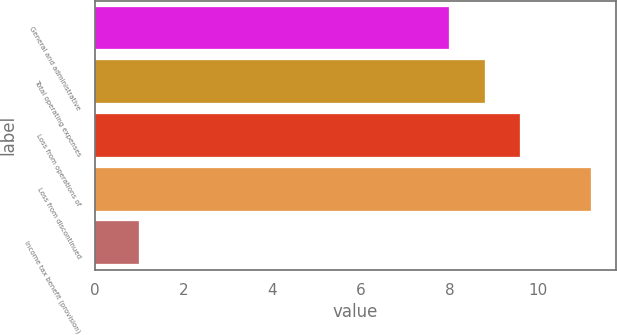Convert chart. <chart><loc_0><loc_0><loc_500><loc_500><bar_chart><fcel>General and administrative<fcel>Total operating expenses<fcel>Loss from operations of<fcel>Loss from discontinued<fcel>Income tax benefit (provision)<nl><fcel>8<fcel>8.8<fcel>9.6<fcel>11.2<fcel>1<nl></chart> 